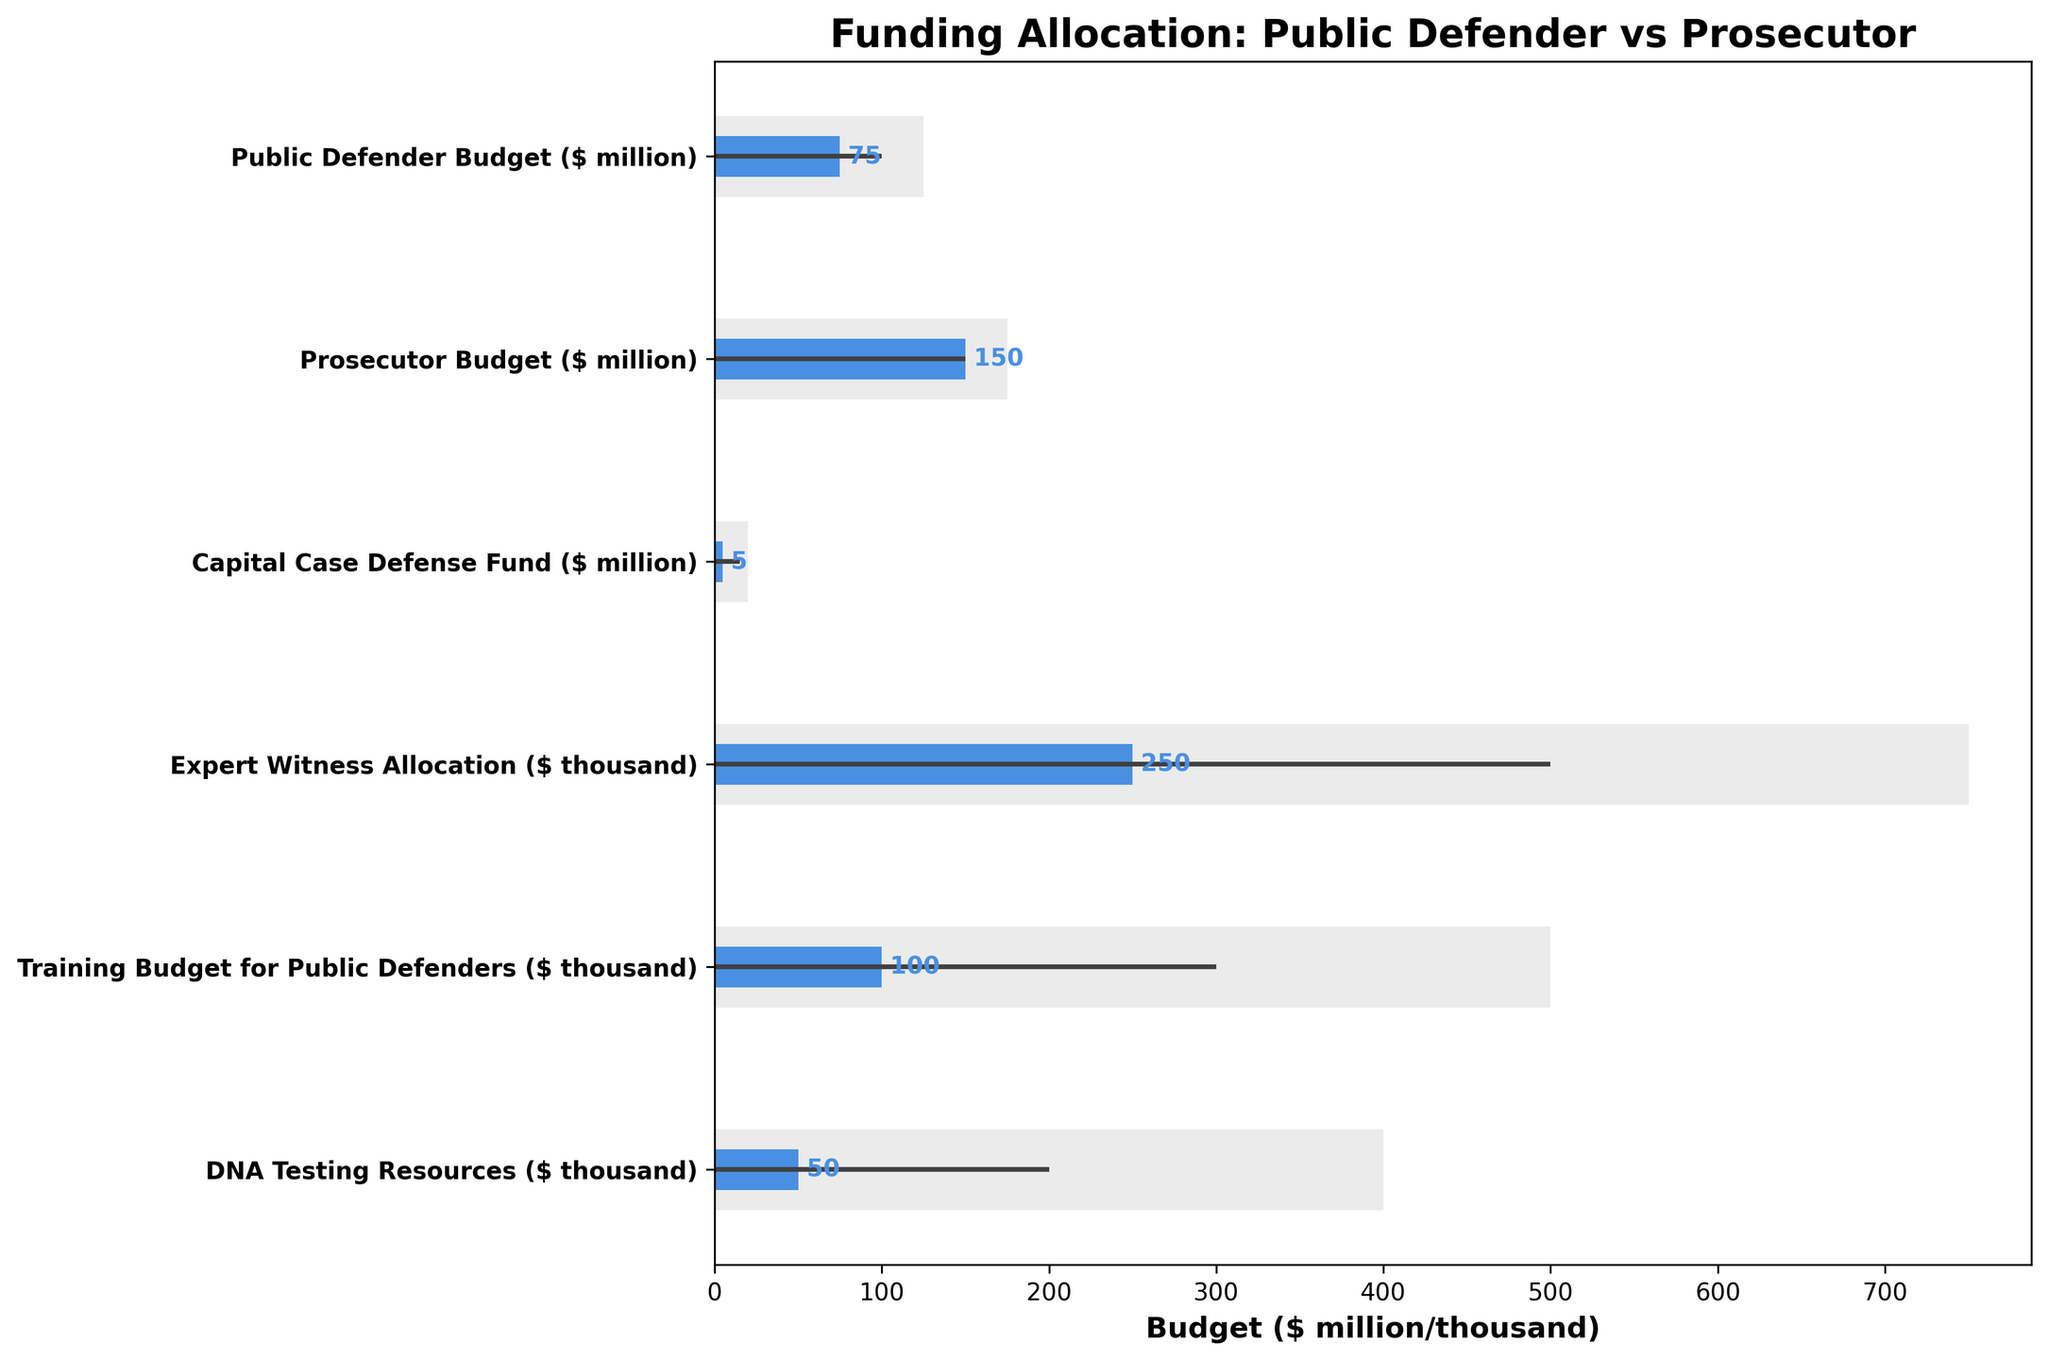what is the title of the chart? The title is the larger text displayed at the top of the chart. Here it reads 'Funding Allocation: Public Defender vs Prosecutor.'
Answer: Funding Allocation: Public Defender vs Prosecutor what is the actual budget for the Public Defender Budget category? The actual budget is represented by the small blue bar for each category. For the Public Defender Budget, the blue bar extends to 75 ($ million).
Answer: 75 what's the difference between the actual and comparative budgets for the Training Budget for Public Defenders category? To find the difference, subtract the actual budget from the comparative budget. Here, the Training Budget for Public Defenders has an actual budget of 100 ($ thousand) and a comparative budget of 500 ($ thousand). So, the difference is 500 - 100.
Answer: 400 which category has the largest difference between the actual and target budgets? Calculate the difference between the actual and target budgets for each category, then identify the category with the greatest difference. The category with the largest difference is the Capital Case Defense Fund (15 - 5 = 10).
Answer: Capital Case Defense Fund which budget allocation exceeds its target? Compare the actual budgets to their respective targets. For the Prosecutor Budget, the actual (150) meets the target (150), but none of the actuals exceed their target.
Answer: None how does the Prosecutor Budget comparative value compare with its target value? For the Prosecutor Budget, the comparative value (175) is greater than the target value (150) by subtracting the target from the comparative (175 - 150).
Answer: 25 is the Expert Witness Allocation closer to its target or comparative budget? Calculate the difference between the actual value and the target and comparative budgets. The actual value is 250 ($ thousand), the target value is 500 ($ thousand), and the comparative value is 750 ($ thousand). The differences are 250 and 500 respectively; thus, it is closer to the target.
Answer: Target which category shows the smallest overall budget, based on the comparative value? Identify the category with the smallest comparative value. The DNA Testing Resources category has the smallest comparative value, which is 400 ($ thousand).
Answer: DNA Testing Resources 